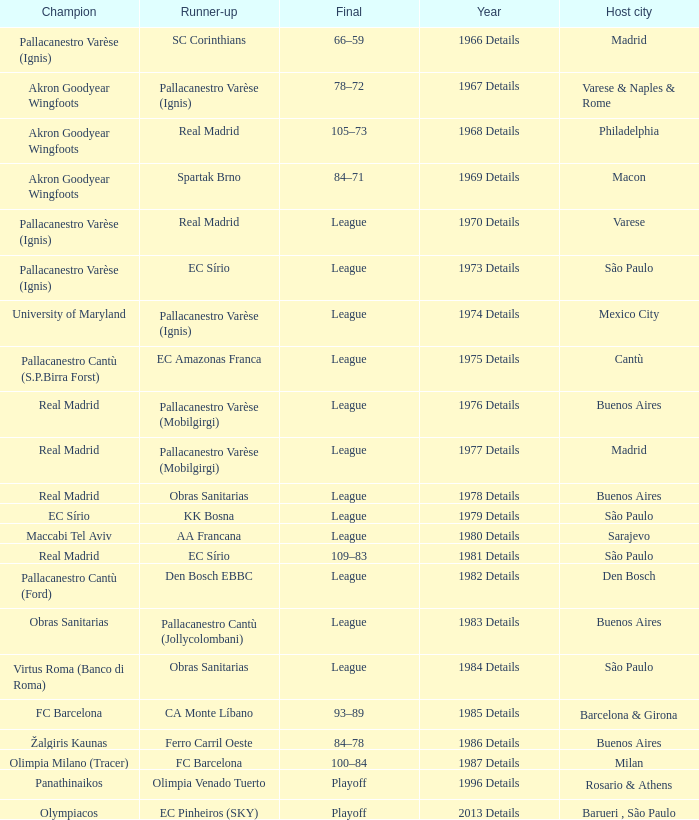What year was the International Cup that was won by Akron Goodyear Wingfoots and had Real Madrid as runner-up? 1968 Details. 